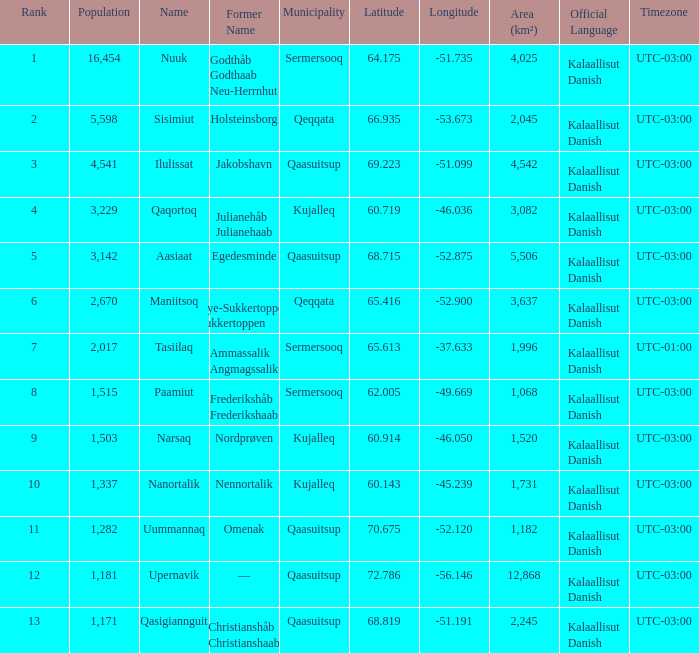Who has a former name of nordprøven? Narsaq. 